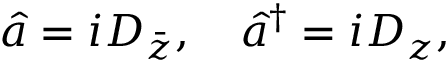<formula> <loc_0><loc_0><loc_500><loc_500>\hat { a } = i { D } _ { \bar { z } } , \quad \hat { a } ^ { \dagger } = i { D } _ { z } ,</formula> 